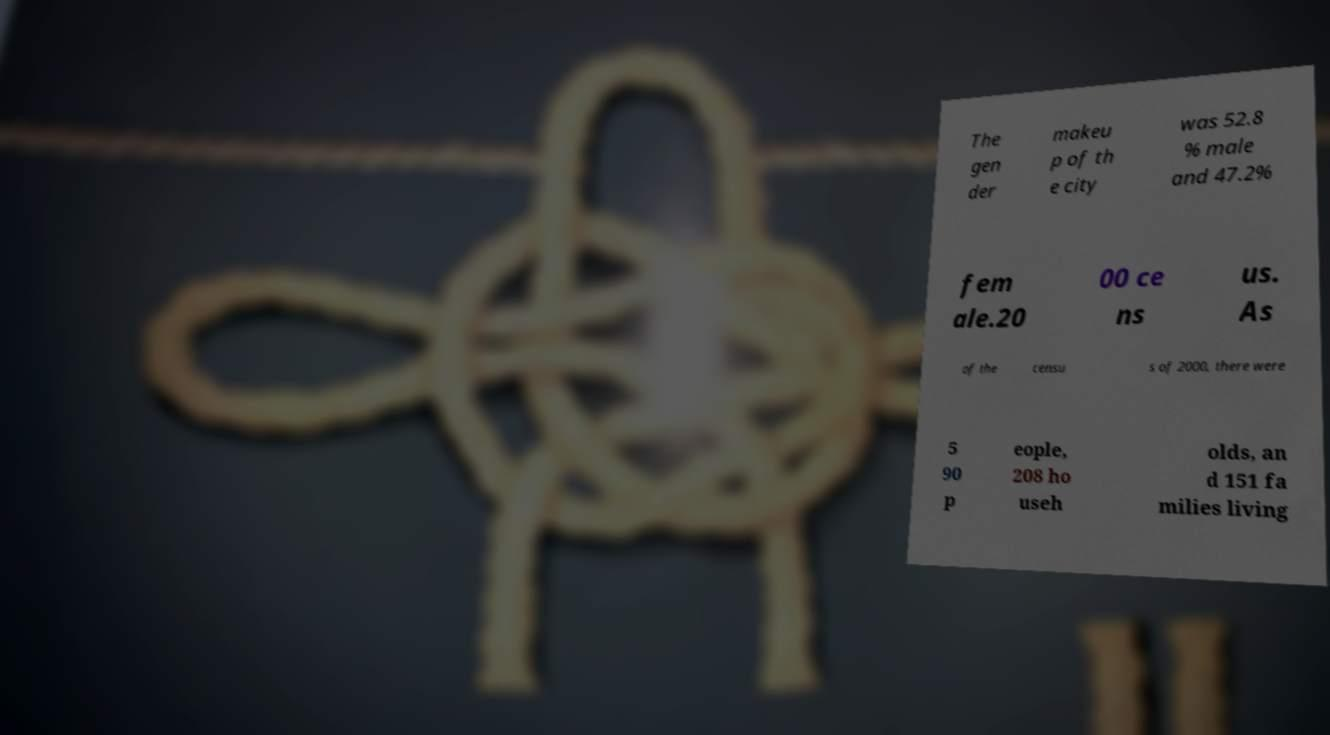Could you assist in decoding the text presented in this image and type it out clearly? The gen der makeu p of th e city was 52.8 % male and 47.2% fem ale.20 00 ce ns us. As of the censu s of 2000, there were 5 90 p eople, 208 ho useh olds, an d 151 fa milies living 